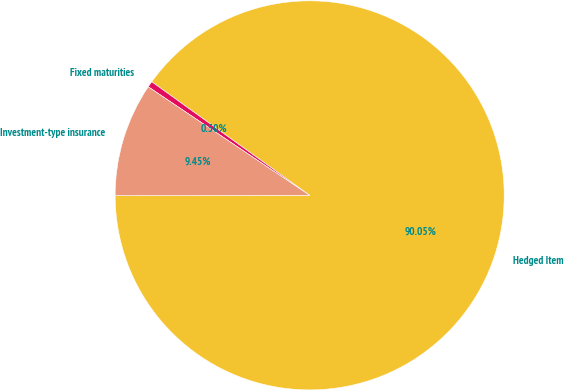<chart> <loc_0><loc_0><loc_500><loc_500><pie_chart><fcel>Hedged Item<fcel>Fixed maturities<fcel>Investment-type insurance<nl><fcel>90.05%<fcel>0.5%<fcel>9.45%<nl></chart> 